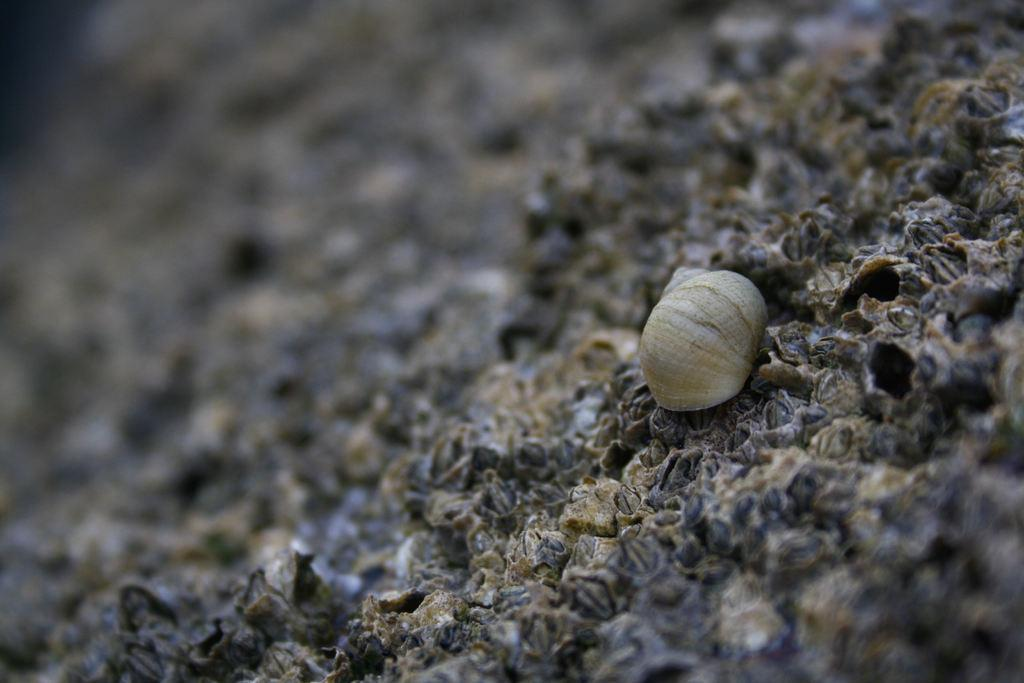What is the main object in the image? There is a shell in the image. Where is the shell located? The shell is on an object that looks like dirt. Can you describe the top part of the image? The top of the image is blurred. What is the sheep reading in the image? There is no sheep or any reading material present in the image. 